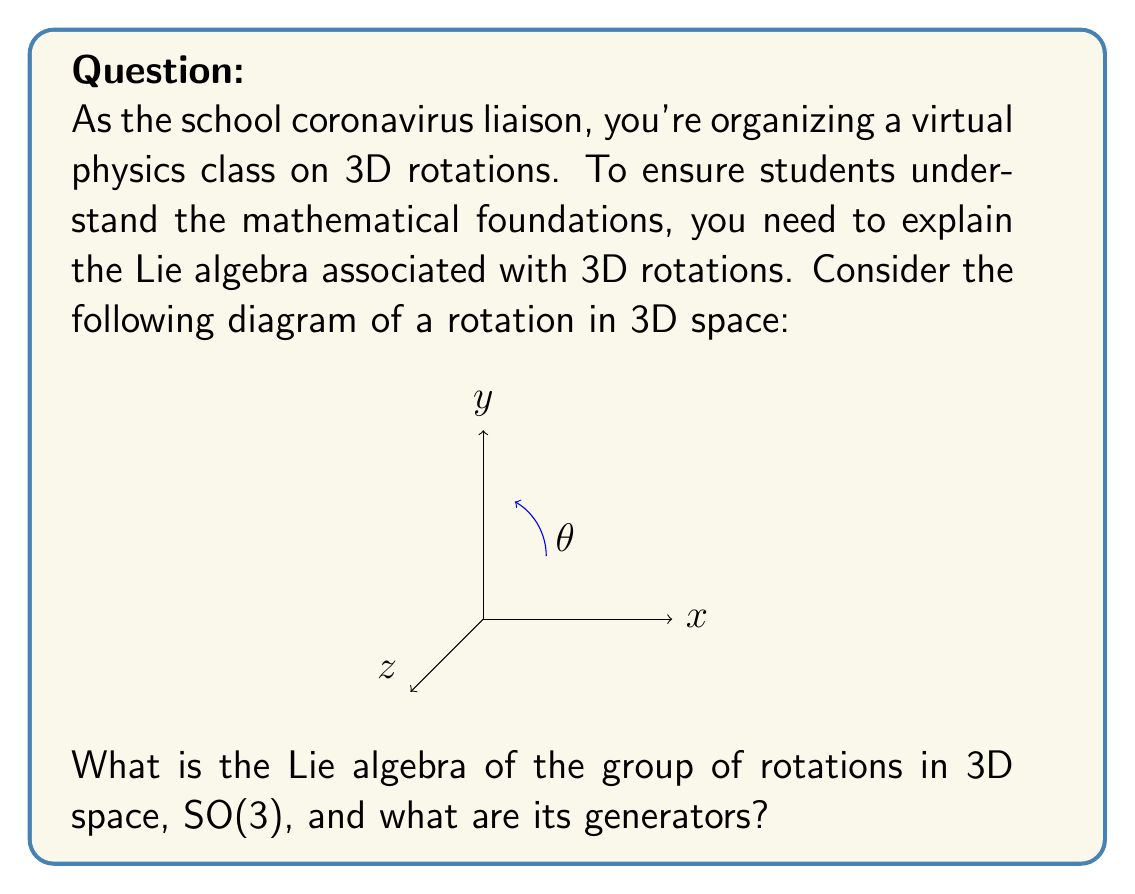Provide a solution to this math problem. To determine the Lie algebra of SO(3), we follow these steps:

1) The group SO(3) consists of 3x3 orthogonal matrices with determinant 1.

2) The Lie algebra so(3) is the tangent space at the identity of SO(3).

3) Elements of so(3) are skew-symmetric 3x3 matrices, i.e., matrices A such that $A^T = -A$.

4) The general form of a skew-symmetric 3x3 matrix is:

   $$A = \begin{pmatrix}
   0 & -a_3 & a_2 \\
   a_3 & 0 & -a_1 \\
   -a_2 & a_1 & 0
   \end{pmatrix}$$

5) We can identify three basis elements (generators) of so(3):

   $$J_1 = \begin{pmatrix}
   0 & 0 & 0 \\
   0 & 0 & -1 \\
   0 & 1 & 0
   \end{pmatrix}, \quad
   J_2 = \begin{pmatrix}
   0 & 0 & 1 \\
   0 & 0 & 0 \\
   -1 & 0 & 0
   \end{pmatrix}, \quad
   J_3 = \begin{pmatrix}
   0 & -1 & 0 \\
   1 & 0 & 0 \\
   0 & 0 & 0
   \end{pmatrix}$$

6) These generators correspond to infinitesimal rotations around the x, y, and z axes, respectively.

7) The Lie bracket of these generators satisfies:

   $$[J_i, J_j] = \epsilon_{ijk} J_k$$

   where $\epsilon_{ijk}$ is the Levi-Civita symbol.

8) This algebra is isomorphic to $\mathfrak{su}(2)$, the Lie algebra of SU(2), which is the double cover of SO(3).
Answer: so(3), generated by $J_1$, $J_2$, $J_3$ 